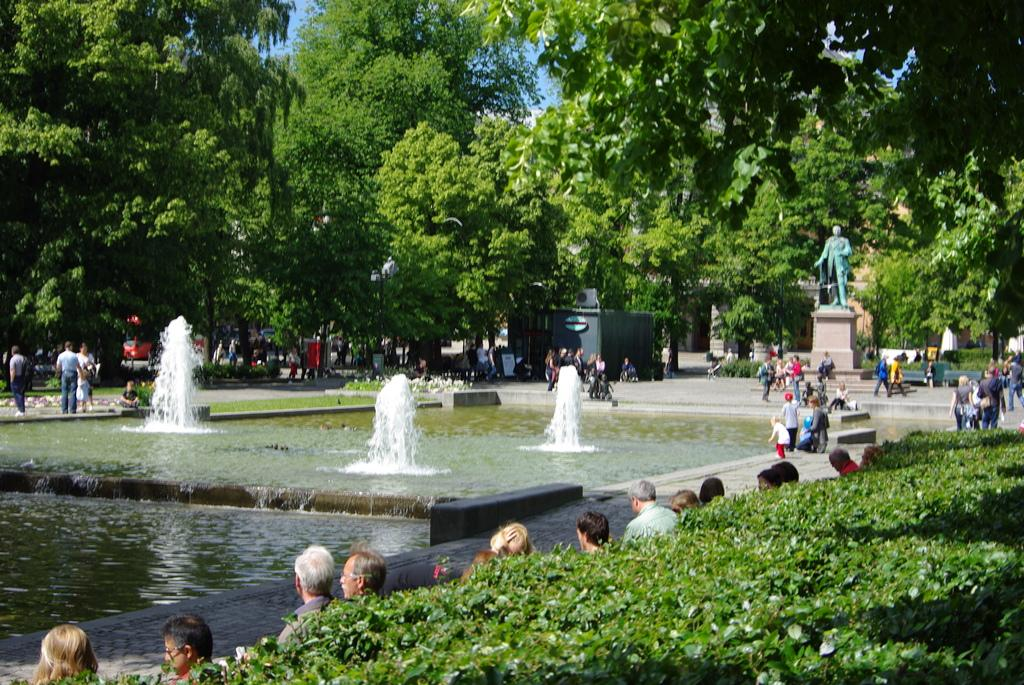How many people can be seen in the image? There are people in the image, but the exact number is not specified. What type of structures are present in the image? There are water fountains, a shed, a statue, and benches in the image. What type of natural elements can be seen in the image? There is grass, plants, trees, and the sky visible in the image. What type of vehicle is present in the image? There is a vehicle in the image, but its specific type is not mentioned. Can you see any leaves falling from the trees in the image? There is no mention of leaves falling from the trees in the image. Is there a giraffe in the image? No, there is no giraffe present in the image. What type of powder is being used to clean the statue in the image? There is no indication of any powder being used to clean the statue in the image. 